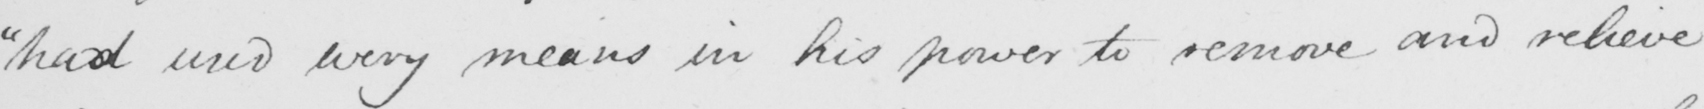Please provide the text content of this handwritten line. " had used every means in his power to remove and relieve 